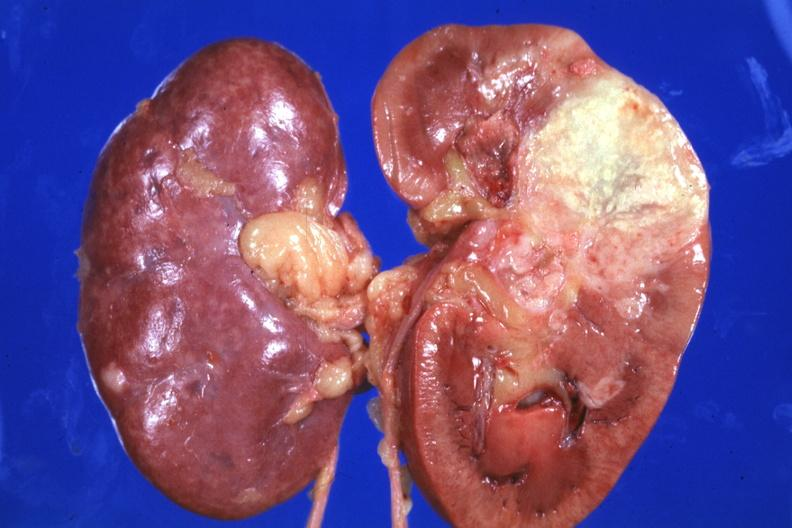s immunostain for growth hormone present?
Answer the question using a single word or phrase. No 